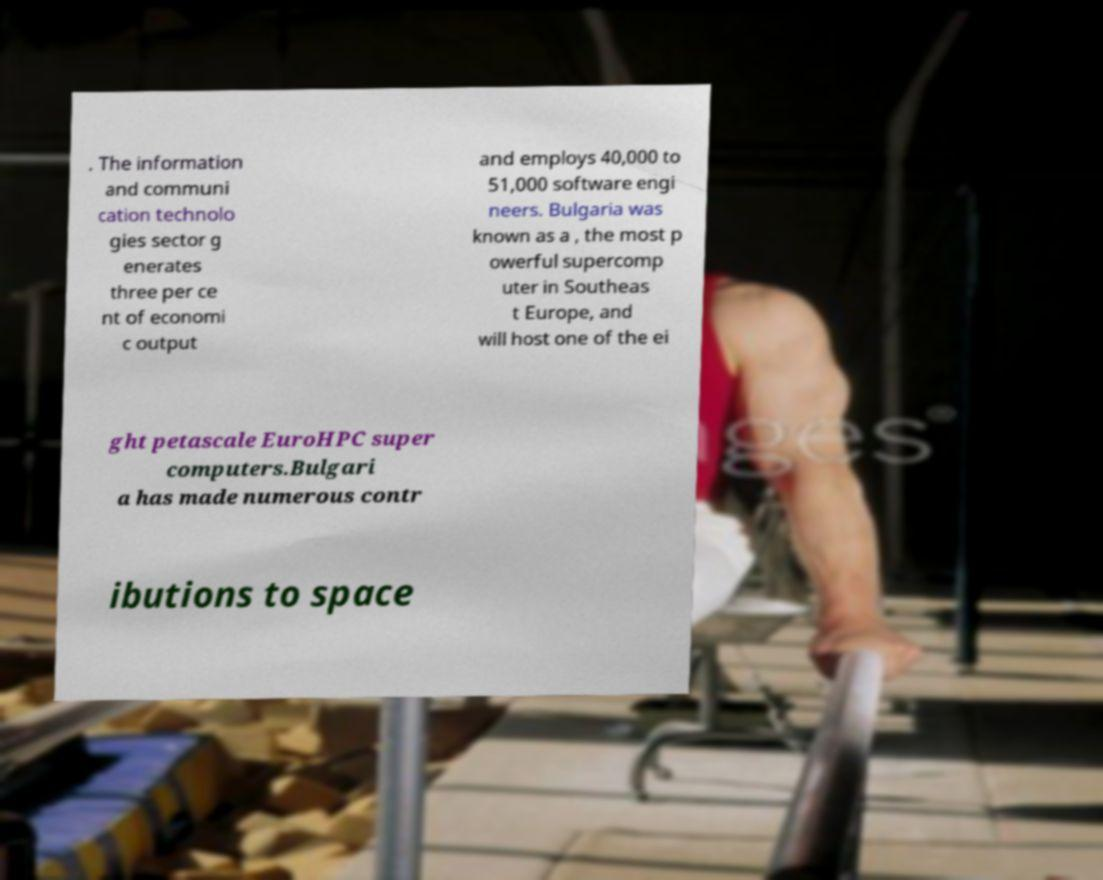Can you accurately transcribe the text from the provided image for me? . The information and communi cation technolo gies sector g enerates three per ce nt of economi c output and employs 40,000 to 51,000 software engi neers. Bulgaria was known as a , the most p owerful supercomp uter in Southeas t Europe, and will host one of the ei ght petascale EuroHPC super computers.Bulgari a has made numerous contr ibutions to space 